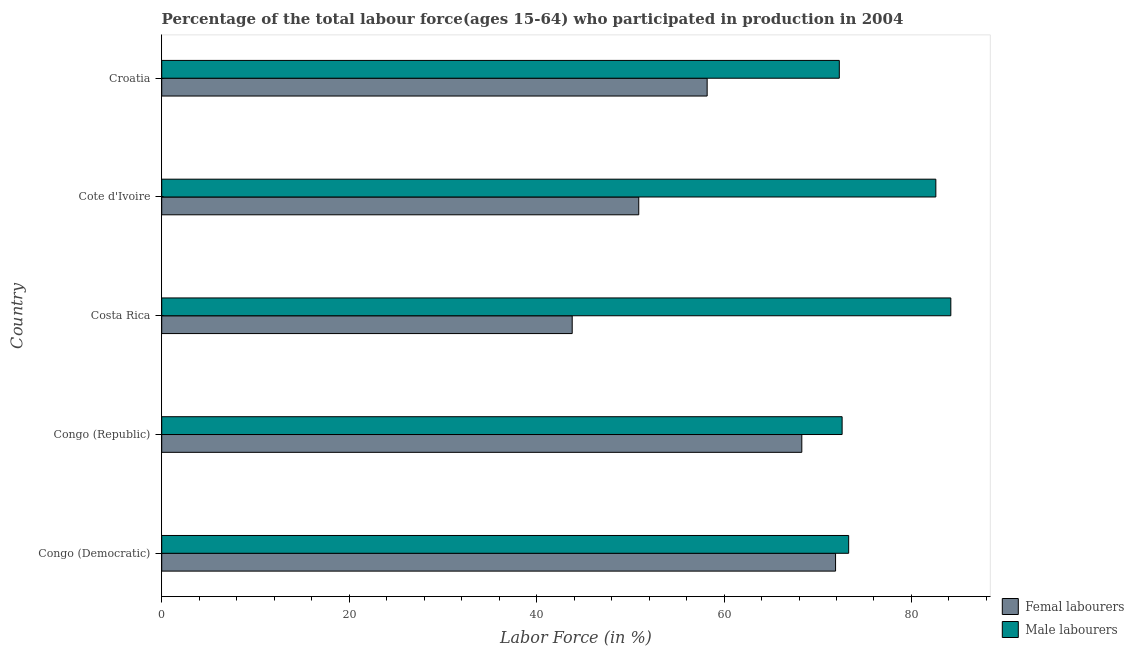How many different coloured bars are there?
Provide a succinct answer. 2. Are the number of bars per tick equal to the number of legend labels?
Provide a succinct answer. Yes. Are the number of bars on each tick of the Y-axis equal?
Provide a succinct answer. Yes. What is the label of the 5th group of bars from the top?
Provide a succinct answer. Congo (Democratic). What is the percentage of female labor force in Congo (Republic)?
Ensure brevity in your answer.  68.3. Across all countries, what is the maximum percentage of male labour force?
Offer a terse response. 84.2. Across all countries, what is the minimum percentage of male labour force?
Your answer should be very brief. 72.3. In which country was the percentage of male labour force maximum?
Keep it short and to the point. Costa Rica. In which country was the percentage of male labour force minimum?
Provide a succinct answer. Croatia. What is the total percentage of male labour force in the graph?
Keep it short and to the point. 385. What is the difference between the percentage of male labour force in Congo (Democratic) and that in Congo (Republic)?
Your response must be concise. 0.7. What is the difference between the percentage of female labor force in Congo (Democratic) and the percentage of male labour force in Congo (Republic)?
Your response must be concise. -0.7. What is the average percentage of male labour force per country?
Give a very brief answer. 77. What is the difference between the percentage of male labour force and percentage of female labor force in Costa Rica?
Provide a succinct answer. 40.4. In how many countries, is the percentage of male labour force greater than 48 %?
Your response must be concise. 5. What is the ratio of the percentage of female labor force in Congo (Democratic) to that in Croatia?
Your answer should be very brief. 1.24. Is the percentage of male labour force in Congo (Democratic) less than that in Costa Rica?
Offer a terse response. Yes. Is the difference between the percentage of male labour force in Costa Rica and Croatia greater than the difference between the percentage of female labor force in Costa Rica and Croatia?
Offer a terse response. Yes. What is the difference between the highest and the second highest percentage of male labour force?
Your answer should be very brief. 1.6. What does the 1st bar from the top in Cote d'Ivoire represents?
Provide a succinct answer. Male labourers. What does the 1st bar from the bottom in Congo (Democratic) represents?
Ensure brevity in your answer.  Femal labourers. How many bars are there?
Ensure brevity in your answer.  10. Are all the bars in the graph horizontal?
Offer a terse response. Yes. What is the difference between two consecutive major ticks on the X-axis?
Provide a succinct answer. 20. Are the values on the major ticks of X-axis written in scientific E-notation?
Provide a succinct answer. No. Does the graph contain any zero values?
Make the answer very short. No. Where does the legend appear in the graph?
Your answer should be very brief. Bottom right. How many legend labels are there?
Your answer should be very brief. 2. What is the title of the graph?
Provide a short and direct response. Percentage of the total labour force(ages 15-64) who participated in production in 2004. What is the label or title of the Y-axis?
Keep it short and to the point. Country. What is the Labor Force (in %) of Femal labourers in Congo (Democratic)?
Ensure brevity in your answer.  71.9. What is the Labor Force (in %) of Male labourers in Congo (Democratic)?
Keep it short and to the point. 73.3. What is the Labor Force (in %) in Femal labourers in Congo (Republic)?
Give a very brief answer. 68.3. What is the Labor Force (in %) of Male labourers in Congo (Republic)?
Ensure brevity in your answer.  72.6. What is the Labor Force (in %) in Femal labourers in Costa Rica?
Offer a terse response. 43.8. What is the Labor Force (in %) of Male labourers in Costa Rica?
Your response must be concise. 84.2. What is the Labor Force (in %) in Femal labourers in Cote d'Ivoire?
Your response must be concise. 50.9. What is the Labor Force (in %) of Male labourers in Cote d'Ivoire?
Keep it short and to the point. 82.6. What is the Labor Force (in %) of Femal labourers in Croatia?
Offer a very short reply. 58.2. What is the Labor Force (in %) of Male labourers in Croatia?
Offer a very short reply. 72.3. Across all countries, what is the maximum Labor Force (in %) in Femal labourers?
Offer a very short reply. 71.9. Across all countries, what is the maximum Labor Force (in %) of Male labourers?
Make the answer very short. 84.2. Across all countries, what is the minimum Labor Force (in %) of Femal labourers?
Keep it short and to the point. 43.8. Across all countries, what is the minimum Labor Force (in %) in Male labourers?
Your response must be concise. 72.3. What is the total Labor Force (in %) of Femal labourers in the graph?
Provide a succinct answer. 293.1. What is the total Labor Force (in %) of Male labourers in the graph?
Your answer should be very brief. 385. What is the difference between the Labor Force (in %) of Male labourers in Congo (Democratic) and that in Congo (Republic)?
Keep it short and to the point. 0.7. What is the difference between the Labor Force (in %) of Femal labourers in Congo (Democratic) and that in Costa Rica?
Offer a terse response. 28.1. What is the difference between the Labor Force (in %) of Male labourers in Congo (Democratic) and that in Costa Rica?
Keep it short and to the point. -10.9. What is the difference between the Labor Force (in %) in Femal labourers in Congo (Democratic) and that in Cote d'Ivoire?
Offer a very short reply. 21. What is the difference between the Labor Force (in %) in Femal labourers in Congo (Democratic) and that in Croatia?
Make the answer very short. 13.7. What is the difference between the Labor Force (in %) of Male labourers in Congo (Democratic) and that in Croatia?
Ensure brevity in your answer.  1. What is the difference between the Labor Force (in %) in Male labourers in Congo (Republic) and that in Costa Rica?
Your response must be concise. -11.6. What is the difference between the Labor Force (in %) in Male labourers in Costa Rica and that in Cote d'Ivoire?
Your response must be concise. 1.6. What is the difference between the Labor Force (in %) of Femal labourers in Costa Rica and that in Croatia?
Provide a short and direct response. -14.4. What is the difference between the Labor Force (in %) in Male labourers in Costa Rica and that in Croatia?
Offer a terse response. 11.9. What is the difference between the Labor Force (in %) in Male labourers in Cote d'Ivoire and that in Croatia?
Offer a very short reply. 10.3. What is the difference between the Labor Force (in %) in Femal labourers in Congo (Democratic) and the Labor Force (in %) in Male labourers in Congo (Republic)?
Provide a short and direct response. -0.7. What is the difference between the Labor Force (in %) in Femal labourers in Congo (Democratic) and the Labor Force (in %) in Male labourers in Cote d'Ivoire?
Provide a short and direct response. -10.7. What is the difference between the Labor Force (in %) of Femal labourers in Congo (Republic) and the Labor Force (in %) of Male labourers in Costa Rica?
Your response must be concise. -15.9. What is the difference between the Labor Force (in %) of Femal labourers in Congo (Republic) and the Labor Force (in %) of Male labourers in Cote d'Ivoire?
Ensure brevity in your answer.  -14.3. What is the difference between the Labor Force (in %) in Femal labourers in Costa Rica and the Labor Force (in %) in Male labourers in Cote d'Ivoire?
Your answer should be very brief. -38.8. What is the difference between the Labor Force (in %) of Femal labourers in Costa Rica and the Labor Force (in %) of Male labourers in Croatia?
Keep it short and to the point. -28.5. What is the difference between the Labor Force (in %) in Femal labourers in Cote d'Ivoire and the Labor Force (in %) in Male labourers in Croatia?
Give a very brief answer. -21.4. What is the average Labor Force (in %) in Femal labourers per country?
Offer a very short reply. 58.62. What is the difference between the Labor Force (in %) of Femal labourers and Labor Force (in %) of Male labourers in Congo (Democratic)?
Give a very brief answer. -1.4. What is the difference between the Labor Force (in %) in Femal labourers and Labor Force (in %) in Male labourers in Congo (Republic)?
Your response must be concise. -4.3. What is the difference between the Labor Force (in %) in Femal labourers and Labor Force (in %) in Male labourers in Costa Rica?
Provide a short and direct response. -40.4. What is the difference between the Labor Force (in %) of Femal labourers and Labor Force (in %) of Male labourers in Cote d'Ivoire?
Your answer should be very brief. -31.7. What is the difference between the Labor Force (in %) in Femal labourers and Labor Force (in %) in Male labourers in Croatia?
Your answer should be very brief. -14.1. What is the ratio of the Labor Force (in %) of Femal labourers in Congo (Democratic) to that in Congo (Republic)?
Make the answer very short. 1.05. What is the ratio of the Labor Force (in %) of Male labourers in Congo (Democratic) to that in Congo (Republic)?
Offer a terse response. 1.01. What is the ratio of the Labor Force (in %) of Femal labourers in Congo (Democratic) to that in Costa Rica?
Your response must be concise. 1.64. What is the ratio of the Labor Force (in %) in Male labourers in Congo (Democratic) to that in Costa Rica?
Make the answer very short. 0.87. What is the ratio of the Labor Force (in %) of Femal labourers in Congo (Democratic) to that in Cote d'Ivoire?
Offer a very short reply. 1.41. What is the ratio of the Labor Force (in %) in Male labourers in Congo (Democratic) to that in Cote d'Ivoire?
Provide a short and direct response. 0.89. What is the ratio of the Labor Force (in %) of Femal labourers in Congo (Democratic) to that in Croatia?
Make the answer very short. 1.24. What is the ratio of the Labor Force (in %) of Male labourers in Congo (Democratic) to that in Croatia?
Your answer should be very brief. 1.01. What is the ratio of the Labor Force (in %) of Femal labourers in Congo (Republic) to that in Costa Rica?
Your response must be concise. 1.56. What is the ratio of the Labor Force (in %) in Male labourers in Congo (Republic) to that in Costa Rica?
Give a very brief answer. 0.86. What is the ratio of the Labor Force (in %) in Femal labourers in Congo (Republic) to that in Cote d'Ivoire?
Provide a short and direct response. 1.34. What is the ratio of the Labor Force (in %) of Male labourers in Congo (Republic) to that in Cote d'Ivoire?
Keep it short and to the point. 0.88. What is the ratio of the Labor Force (in %) in Femal labourers in Congo (Republic) to that in Croatia?
Offer a very short reply. 1.17. What is the ratio of the Labor Force (in %) in Male labourers in Congo (Republic) to that in Croatia?
Your answer should be compact. 1. What is the ratio of the Labor Force (in %) in Femal labourers in Costa Rica to that in Cote d'Ivoire?
Give a very brief answer. 0.86. What is the ratio of the Labor Force (in %) in Male labourers in Costa Rica to that in Cote d'Ivoire?
Your response must be concise. 1.02. What is the ratio of the Labor Force (in %) of Femal labourers in Costa Rica to that in Croatia?
Provide a succinct answer. 0.75. What is the ratio of the Labor Force (in %) in Male labourers in Costa Rica to that in Croatia?
Provide a succinct answer. 1.16. What is the ratio of the Labor Force (in %) in Femal labourers in Cote d'Ivoire to that in Croatia?
Make the answer very short. 0.87. What is the ratio of the Labor Force (in %) of Male labourers in Cote d'Ivoire to that in Croatia?
Offer a very short reply. 1.14. What is the difference between the highest and the second highest Labor Force (in %) of Femal labourers?
Offer a terse response. 3.6. What is the difference between the highest and the lowest Labor Force (in %) in Femal labourers?
Provide a succinct answer. 28.1. What is the difference between the highest and the lowest Labor Force (in %) in Male labourers?
Your response must be concise. 11.9. 